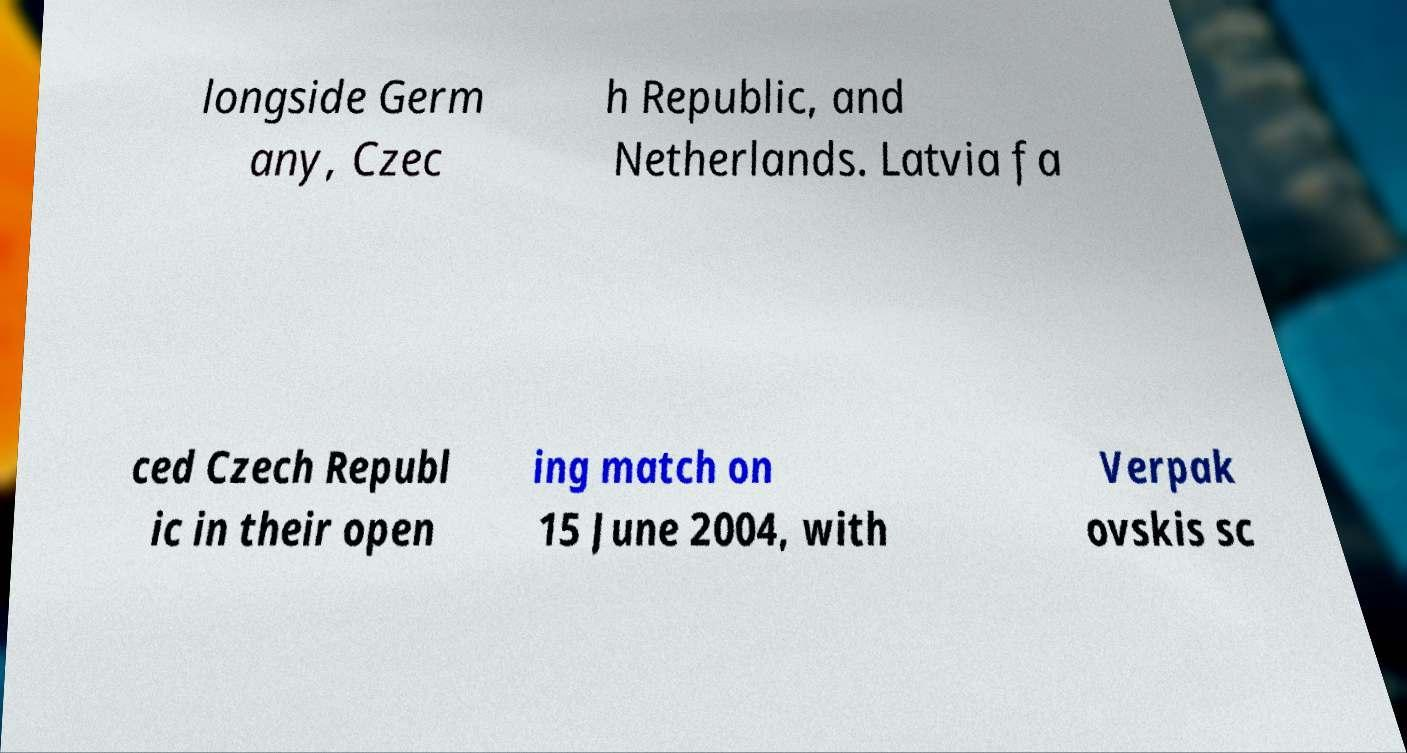Could you extract and type out the text from this image? longside Germ any, Czec h Republic, and Netherlands. Latvia fa ced Czech Republ ic in their open ing match on 15 June 2004, with Verpak ovskis sc 